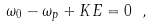<formula> <loc_0><loc_0><loc_500><loc_500>\omega _ { 0 } - \omega _ { p } + K E = 0 \ ,</formula> 